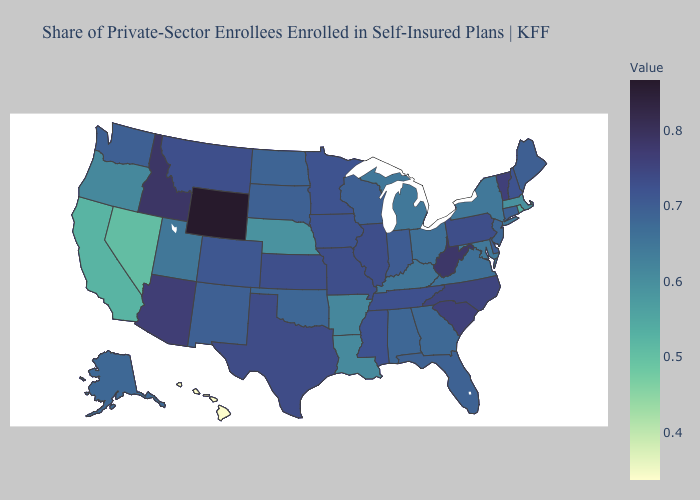Which states hav the highest value in the Northeast?
Concise answer only. Vermont. Which states hav the highest value in the Northeast?
Short answer required. Vermont. Which states have the lowest value in the USA?
Be succinct. Hawaii. Does Vermont have the highest value in the Northeast?
Quick response, please. Yes. Does Colorado have the lowest value in the West?
Answer briefly. No. Among the states that border Michigan , does Ohio have the lowest value?
Answer briefly. Yes. Does Hawaii have the lowest value in the USA?
Write a very short answer. Yes. 